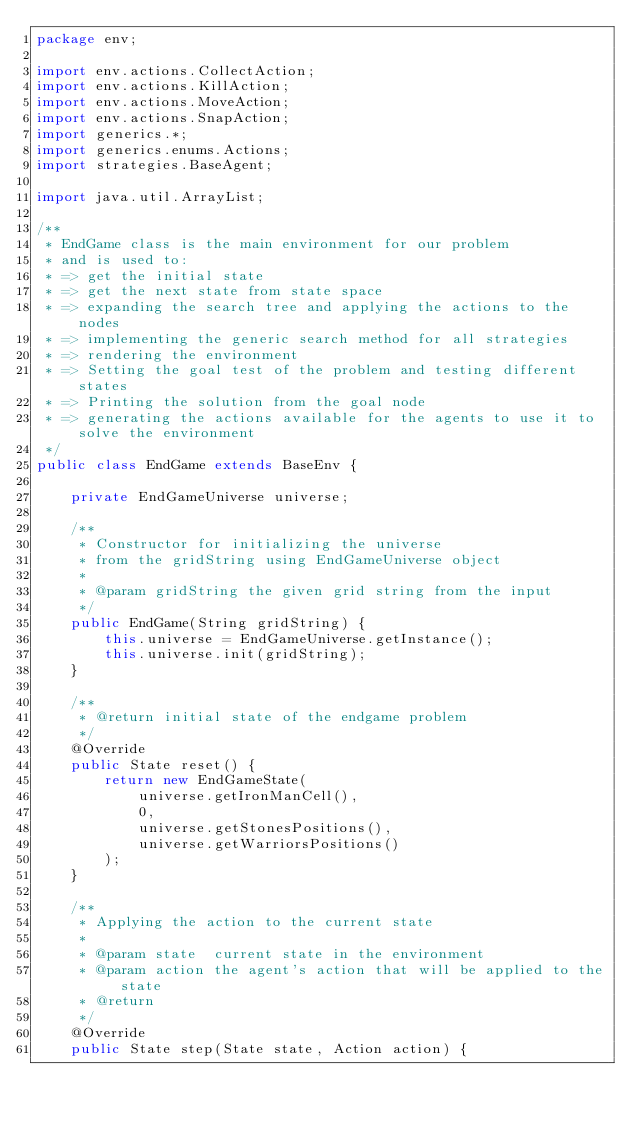<code> <loc_0><loc_0><loc_500><loc_500><_Java_>package env;

import env.actions.CollectAction;
import env.actions.KillAction;
import env.actions.MoveAction;
import env.actions.SnapAction;
import generics.*;
import generics.enums.Actions;
import strategies.BaseAgent;

import java.util.ArrayList;

/**
 * EndGame class is the main environment for our problem
 * and is used to:
 * => get the initial state
 * => get the next state from state space
 * => expanding the search tree and applying the actions to the nodes
 * => implementing the generic search method for all strategies
 * => rendering the environment
 * => Setting the goal test of the problem and testing different states
 * => Printing the solution from the goal node
 * => generating the actions available for the agents to use it to solve the environment
 */
public class EndGame extends BaseEnv {

	private EndGameUniverse universe;

	/**
	 * Constructor for initializing the universe
	 * from the gridString using EndGameUniverse object
	 *
	 * @param gridString the given grid string from the input
	 */
	public EndGame(String gridString) {
		this.universe = EndGameUniverse.getInstance();
		this.universe.init(gridString);
	}

	/**
	 * @return initial state of the endgame problem
	 */
	@Override
	public State reset() {
		return new EndGameState(
			universe.getIronManCell(),
			0,
			universe.getStonesPositions(),
			universe.getWarriorsPositions()
		);
	}

	/**
	 * Applying the action to the current state
	 *
	 * @param state  current state in the environment
	 * @param action the agent's action that will be applied to the state
	 * @return
	 */
	@Override
	public State step(State state, Action action) {</code> 